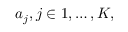Convert formula to latex. <formula><loc_0><loc_0><loc_500><loc_500>a _ { j } , j \in { 1 , \dots , K } ,</formula> 